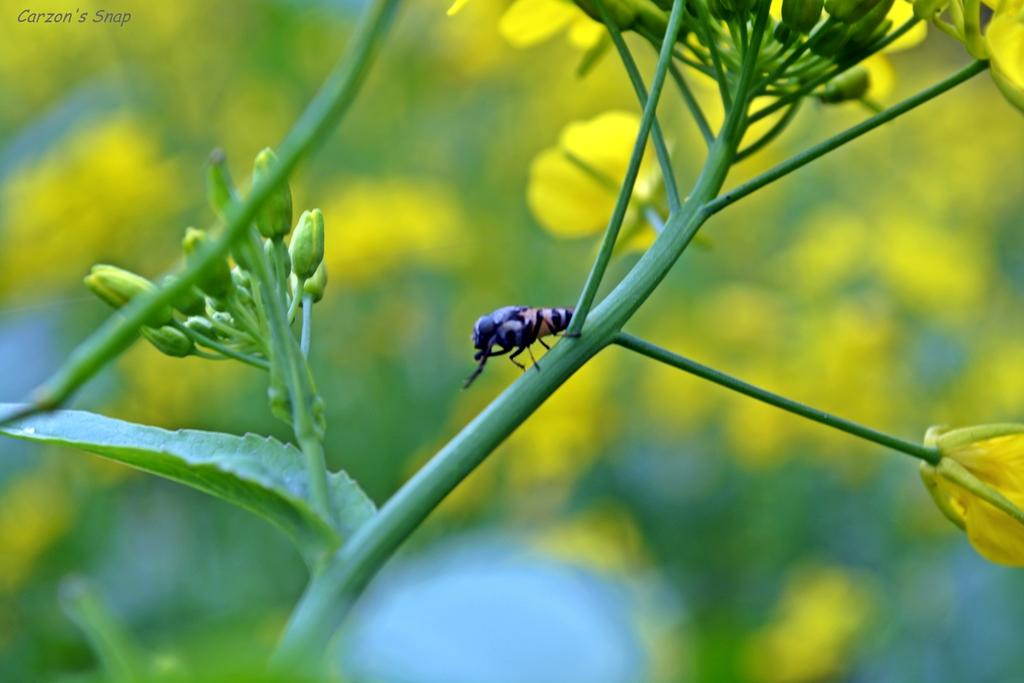What is present on the stem in the image? There is an insect and flowers on the stem in the image. Can you describe the insect on the stem? The insect on the stem is not specified in the facts, but it is present on the stem. What else can be seen on the stem besides the insect? There are flowers on the stem in the image. What type of knife is being used to cut the cabbage in the image? There is no knife or cabbage present in the image; it only features a stem with an insect and flowers. What season is depicted in the image? The facts provided do not mention any season or time of year, so it cannot be determined from the image. 